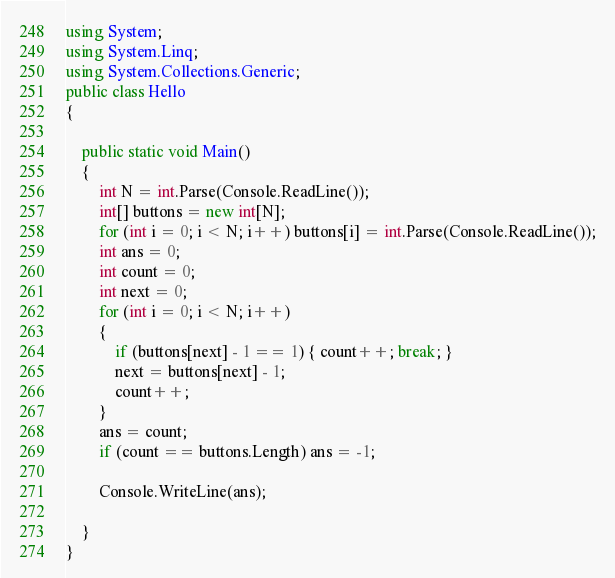Convert code to text. <code><loc_0><loc_0><loc_500><loc_500><_C#_>using System;
using System.Linq;
using System.Collections.Generic;
public class Hello
{

    public static void Main()
    {
        int N = int.Parse(Console.ReadLine());
        int[] buttons = new int[N];
        for (int i = 0; i < N; i++) buttons[i] = int.Parse(Console.ReadLine());
        int ans = 0;
        int count = 0;
        int next = 0;
        for (int i = 0; i < N; i++)
        {
            if (buttons[next] - 1 == 1) { count++; break; }
            next = buttons[next] - 1;
            count++;
        }
        ans = count;
        if (count == buttons.Length) ans = -1;

        Console.WriteLine(ans);

    }
}</code> 